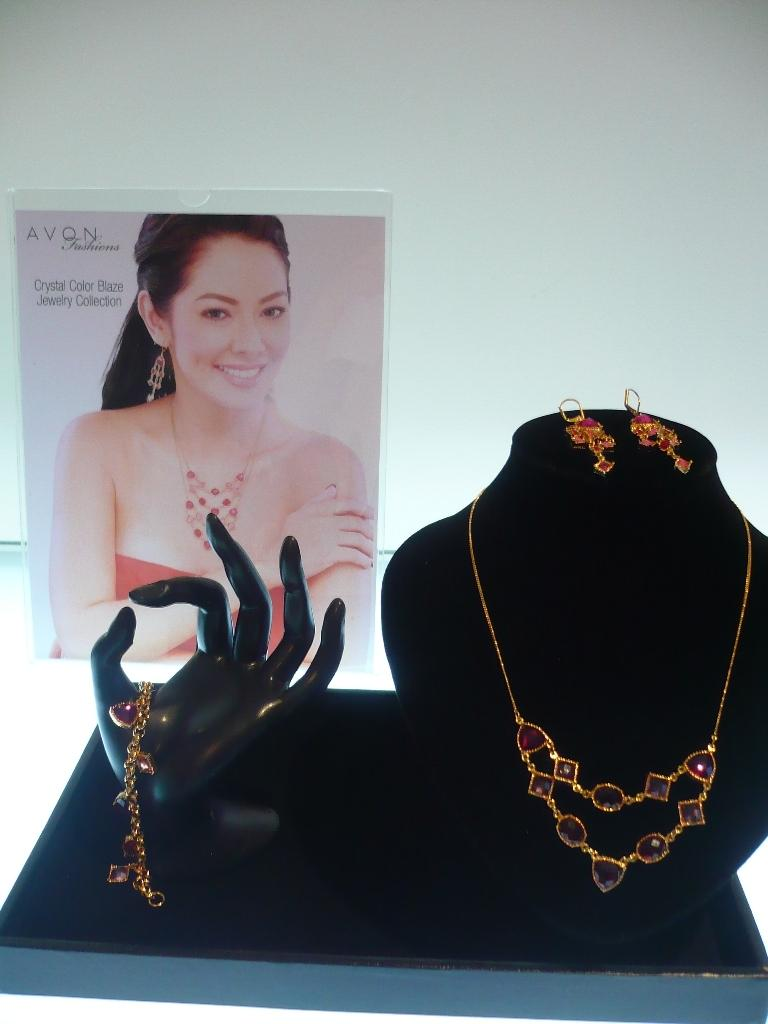What is the main subject of the image? The main subject of the image is jewelry on a glass surface. Are there any accessories for displaying the jewelry? Yes, there are necklace stands present in the image. What can be seen in the background of the image? A poster and a wall are visible in the background of the image. How is the woman in the image reacting to the jewelry? The woman is smiling and looking at the jewelry. How many cats are sitting on the paper in the image? There are no cats or paper present in the image. What effect does the jewelry have on the woman's mood in the image? The image does not explicitly show the effect of the jewelry on the woman's mood, but she is smiling while looking at the jewelry, which suggests a positive effect. 